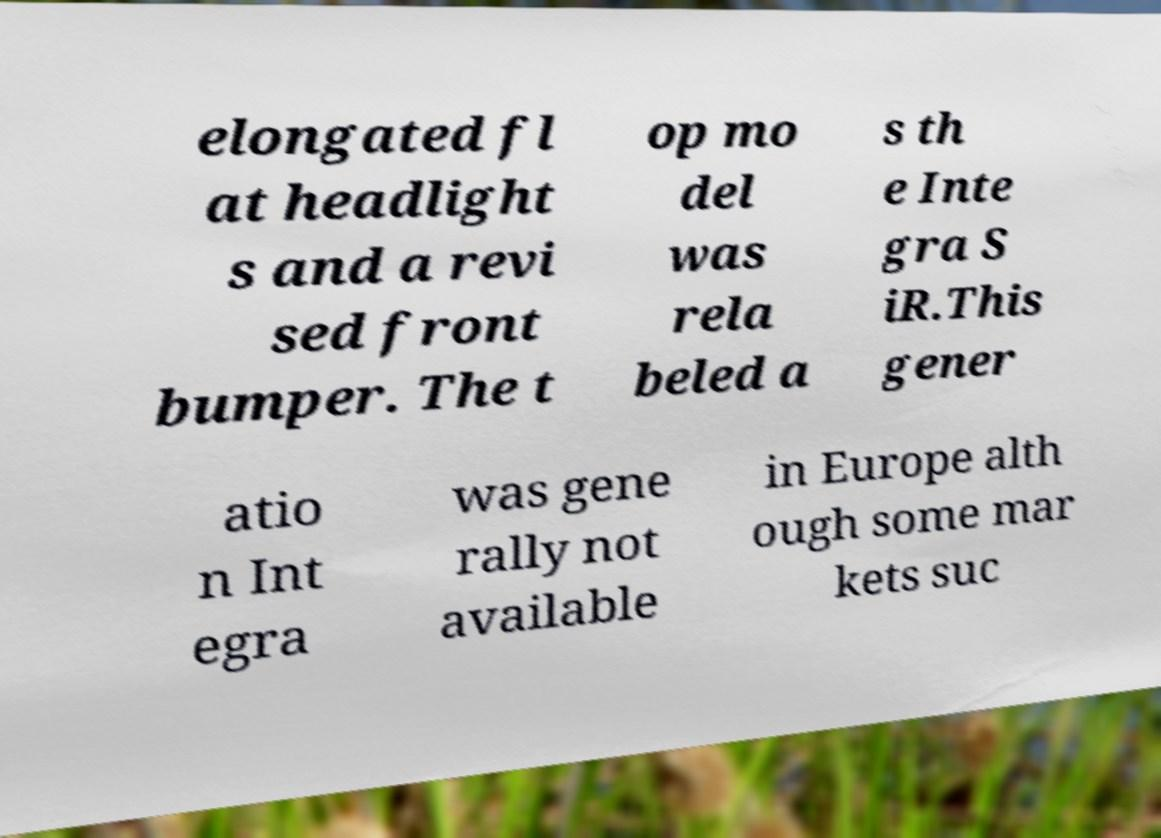Please read and relay the text visible in this image. What does it say? elongated fl at headlight s and a revi sed front bumper. The t op mo del was rela beled a s th e Inte gra S iR.This gener atio n Int egra was gene rally not available in Europe alth ough some mar kets suc 